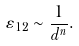Convert formula to latex. <formula><loc_0><loc_0><loc_500><loc_500>\varepsilon _ { 1 2 } \sim \frac { 1 } { d ^ { n } } .</formula> 